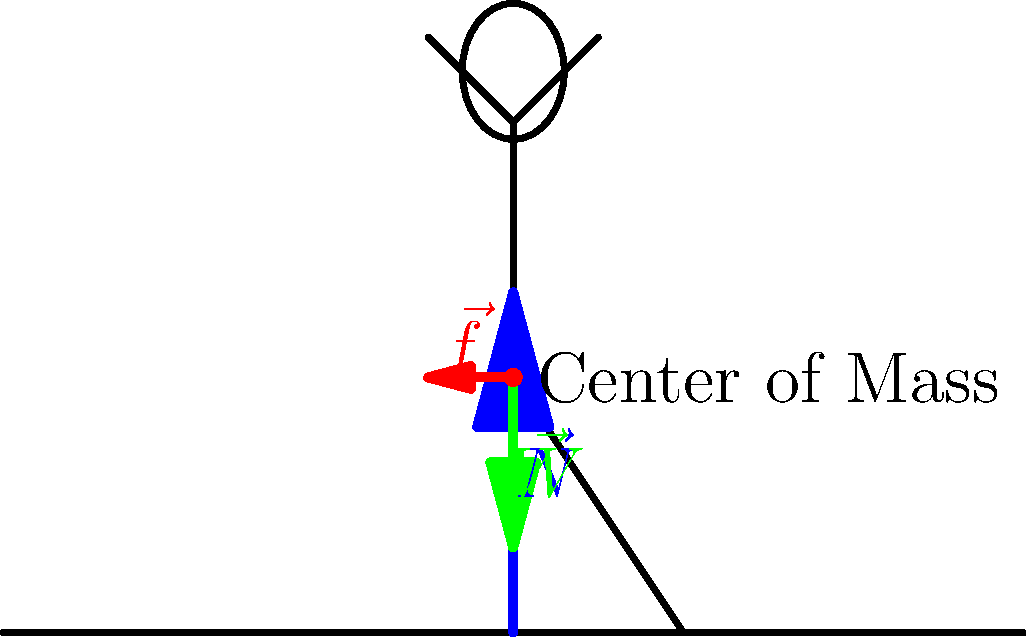In the tree pose shown, a yogi with a mass of 60 kg is balancing on one foot. If the coefficient of static friction between the foot and the ground is 0.5, what is the maximum angle $\theta$ (in degrees) that the yogi can lean to the side before slipping? Assume $g = 9.8$ m/s². Let's approach this step-by-step:

1) First, we need to identify the forces acting on the yogi:
   - Weight ($\vec{W}$) acts downward
   - Normal force ($\vec{N}$) acts upward from the ground
   - Friction force ($\vec{f}$) acts horizontally to prevent slipping

2) At the moment just before slipping, the friction force will be at its maximum:

   $f_{max} = \mu_s N$

   where $\mu_s$ is the coefficient of static friction.

3) The normal force is equal to the weight of the yogi:

   $N = mg = 60 \cdot 9.8 = 588$ N

4) So the maximum friction force is:

   $f_{max} = 0.5 \cdot 588 = 294$ N

5) Now, imagine the yogi leaning at an angle $\theta$. The component of weight causing them to slip is $W \sin \theta$. At the moment of slipping, this will equal the maximum friction:

   $W \sin \theta = f_{max}$

6) Substituting the values:

   $588 \sin \theta = 294$

7) Solving for $\theta$:

   $\sin \theta = \frac{294}{588} = 0.5$

8) Therefore:

   $\theta = \arcsin(0.5) \approx 30°$
Answer: $30°$ 